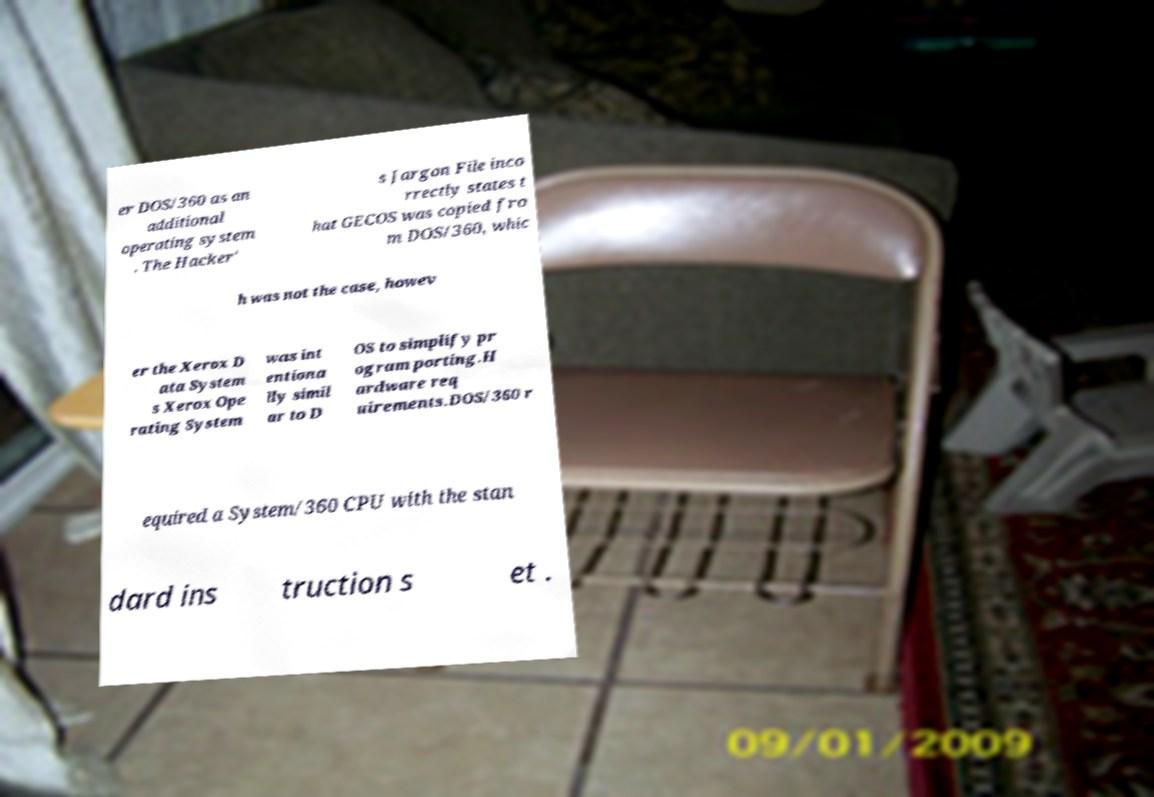Could you assist in decoding the text presented in this image and type it out clearly? er DOS/360 as an additional operating system . The Hacker' s Jargon File inco rrectly states t hat GECOS was copied fro m DOS/360, whic h was not the case, howev er the Xerox D ata System s Xerox Ope rating System was int entiona lly simil ar to D OS to simplify pr ogram porting.H ardware req uirements.DOS/360 r equired a System/360 CPU with the stan dard ins truction s et . 